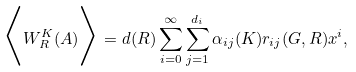<formula> <loc_0><loc_0><loc_500><loc_500>\Big { \langle } W _ { R } ^ { K } ( A ) \Big { \rangle } = d ( R ) \sum _ { i = 0 } ^ { \infty } \sum _ { j = 1 } ^ { d _ { i } } \alpha _ { i j } ( K ) r _ { i j } ( G , R ) x ^ { i } ,</formula> 